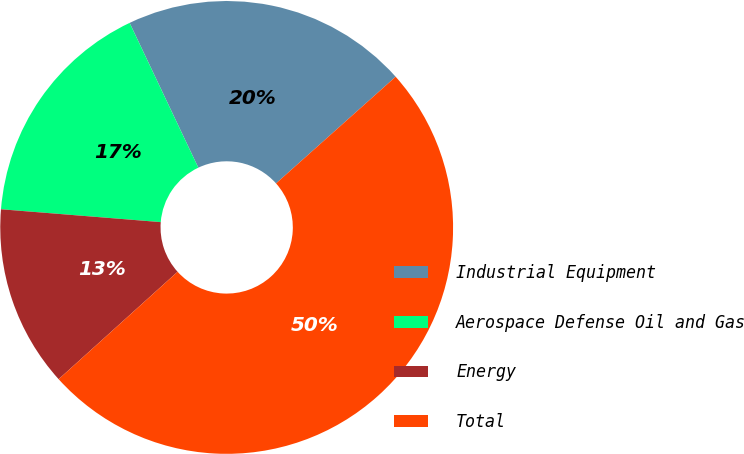<chart> <loc_0><loc_0><loc_500><loc_500><pie_chart><fcel>Industrial Equipment<fcel>Aerospace Defense Oil and Gas<fcel>Energy<fcel>Total<nl><fcel>20.46%<fcel>16.67%<fcel>12.97%<fcel>49.9%<nl></chart> 